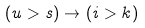Convert formula to latex. <formula><loc_0><loc_0><loc_500><loc_500>( u > s ) \rightarrow ( i > k )</formula> 